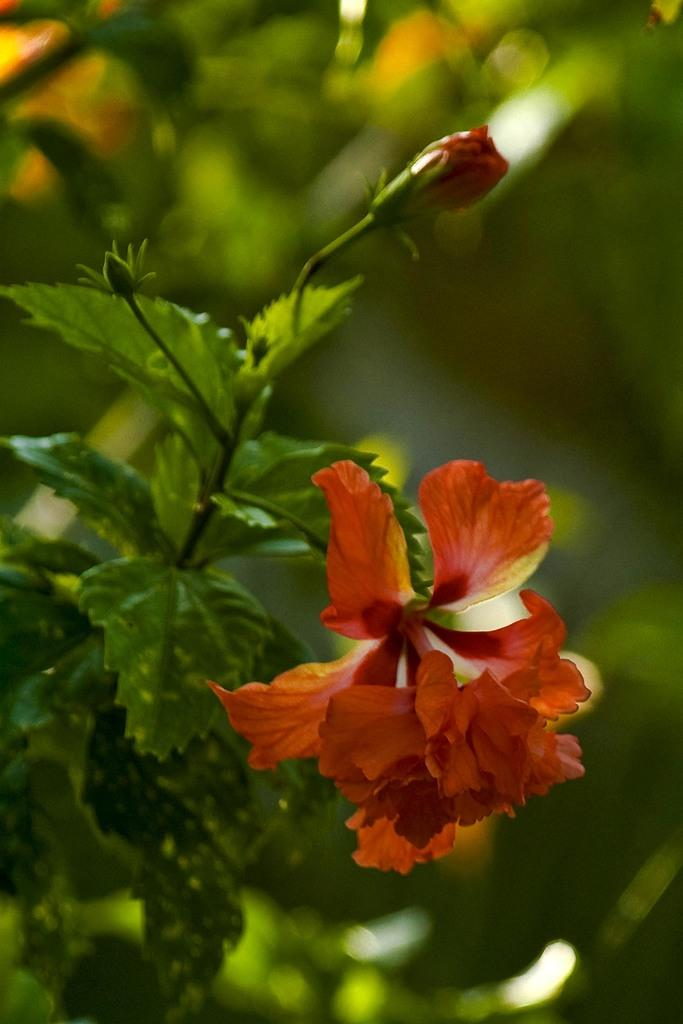What can be seen in the foreground of the picture? There are flowers, buds, and leaves in the foreground of the picture. What is the condition of the background in the image? The background of the image is blurred. What type of vegetation is visible in the background of the picture? There is greenery in the background of the picture. What type of verse can be heard recited in the background of the image? There is no sound or verse present in the image; it is a still photograph of flowers, buds, and leaves. 